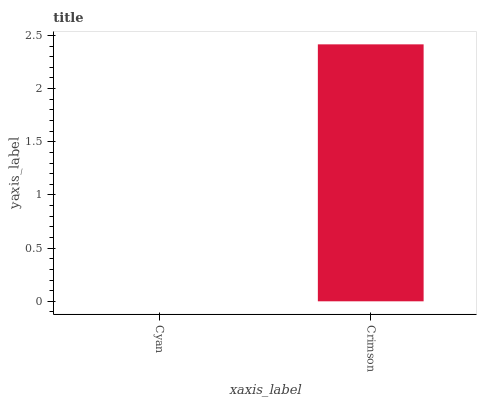Is Crimson the minimum?
Answer yes or no. No. Is Crimson greater than Cyan?
Answer yes or no. Yes. Is Cyan less than Crimson?
Answer yes or no. Yes. Is Cyan greater than Crimson?
Answer yes or no. No. Is Crimson less than Cyan?
Answer yes or no. No. Is Crimson the high median?
Answer yes or no. Yes. Is Cyan the low median?
Answer yes or no. Yes. Is Cyan the high median?
Answer yes or no. No. Is Crimson the low median?
Answer yes or no. No. 